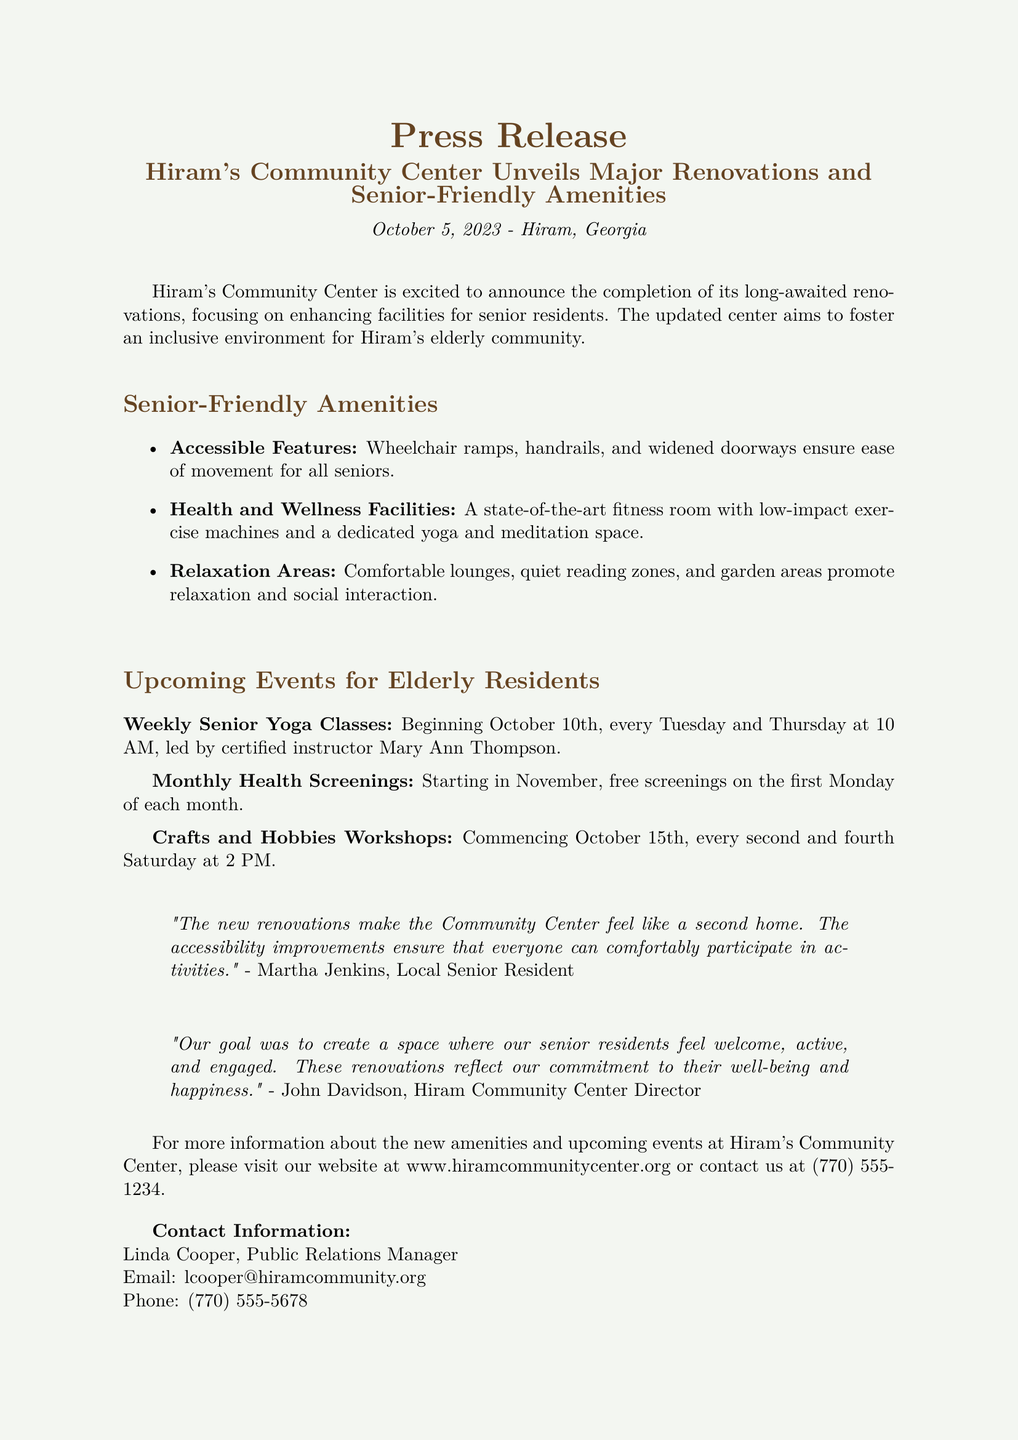What is the date of the press release? The press release states that it was issued on October 5, 2023.
Answer: October 5, 2023 What new fitness feature is available at the community center? The document mentions a state-of-the-art fitness room with low-impact exercise machines.
Answer: Fitness room When do the weekly senior yoga classes begin? The press release indicates that yoga classes start on October 10th.
Answer: October 10th Who is the certified instructor for the yoga classes? The press release names Mary Ann Thompson as the instructor for the yoga classes.
Answer: Mary Ann Thompson What is one type of event offered monthly for seniors? The release lists monthly health screenings as an event for seniors.
Answer: Health screenings What accessibility features are included in the renovations? The document describes wheelchair ramps, handrails, and widened doorways as accessibility features.
Answer: Wheelchair ramps What is the purpose of the community center renovations? The purpose mentioned is to create an inclusive environment for Hiram's elderly community.
Answer: Inclusive environment Who is the Public Relations Manager for the Community Center? The document states that Linda Cooper holds the position of Public Relations Manager.
Answer: Linda Cooper How often will the Crafts and Hobbies Workshops occur? The press release notes that these workshops will occur every second and fourth Saturday.
Answer: Every second and fourth Saturday 